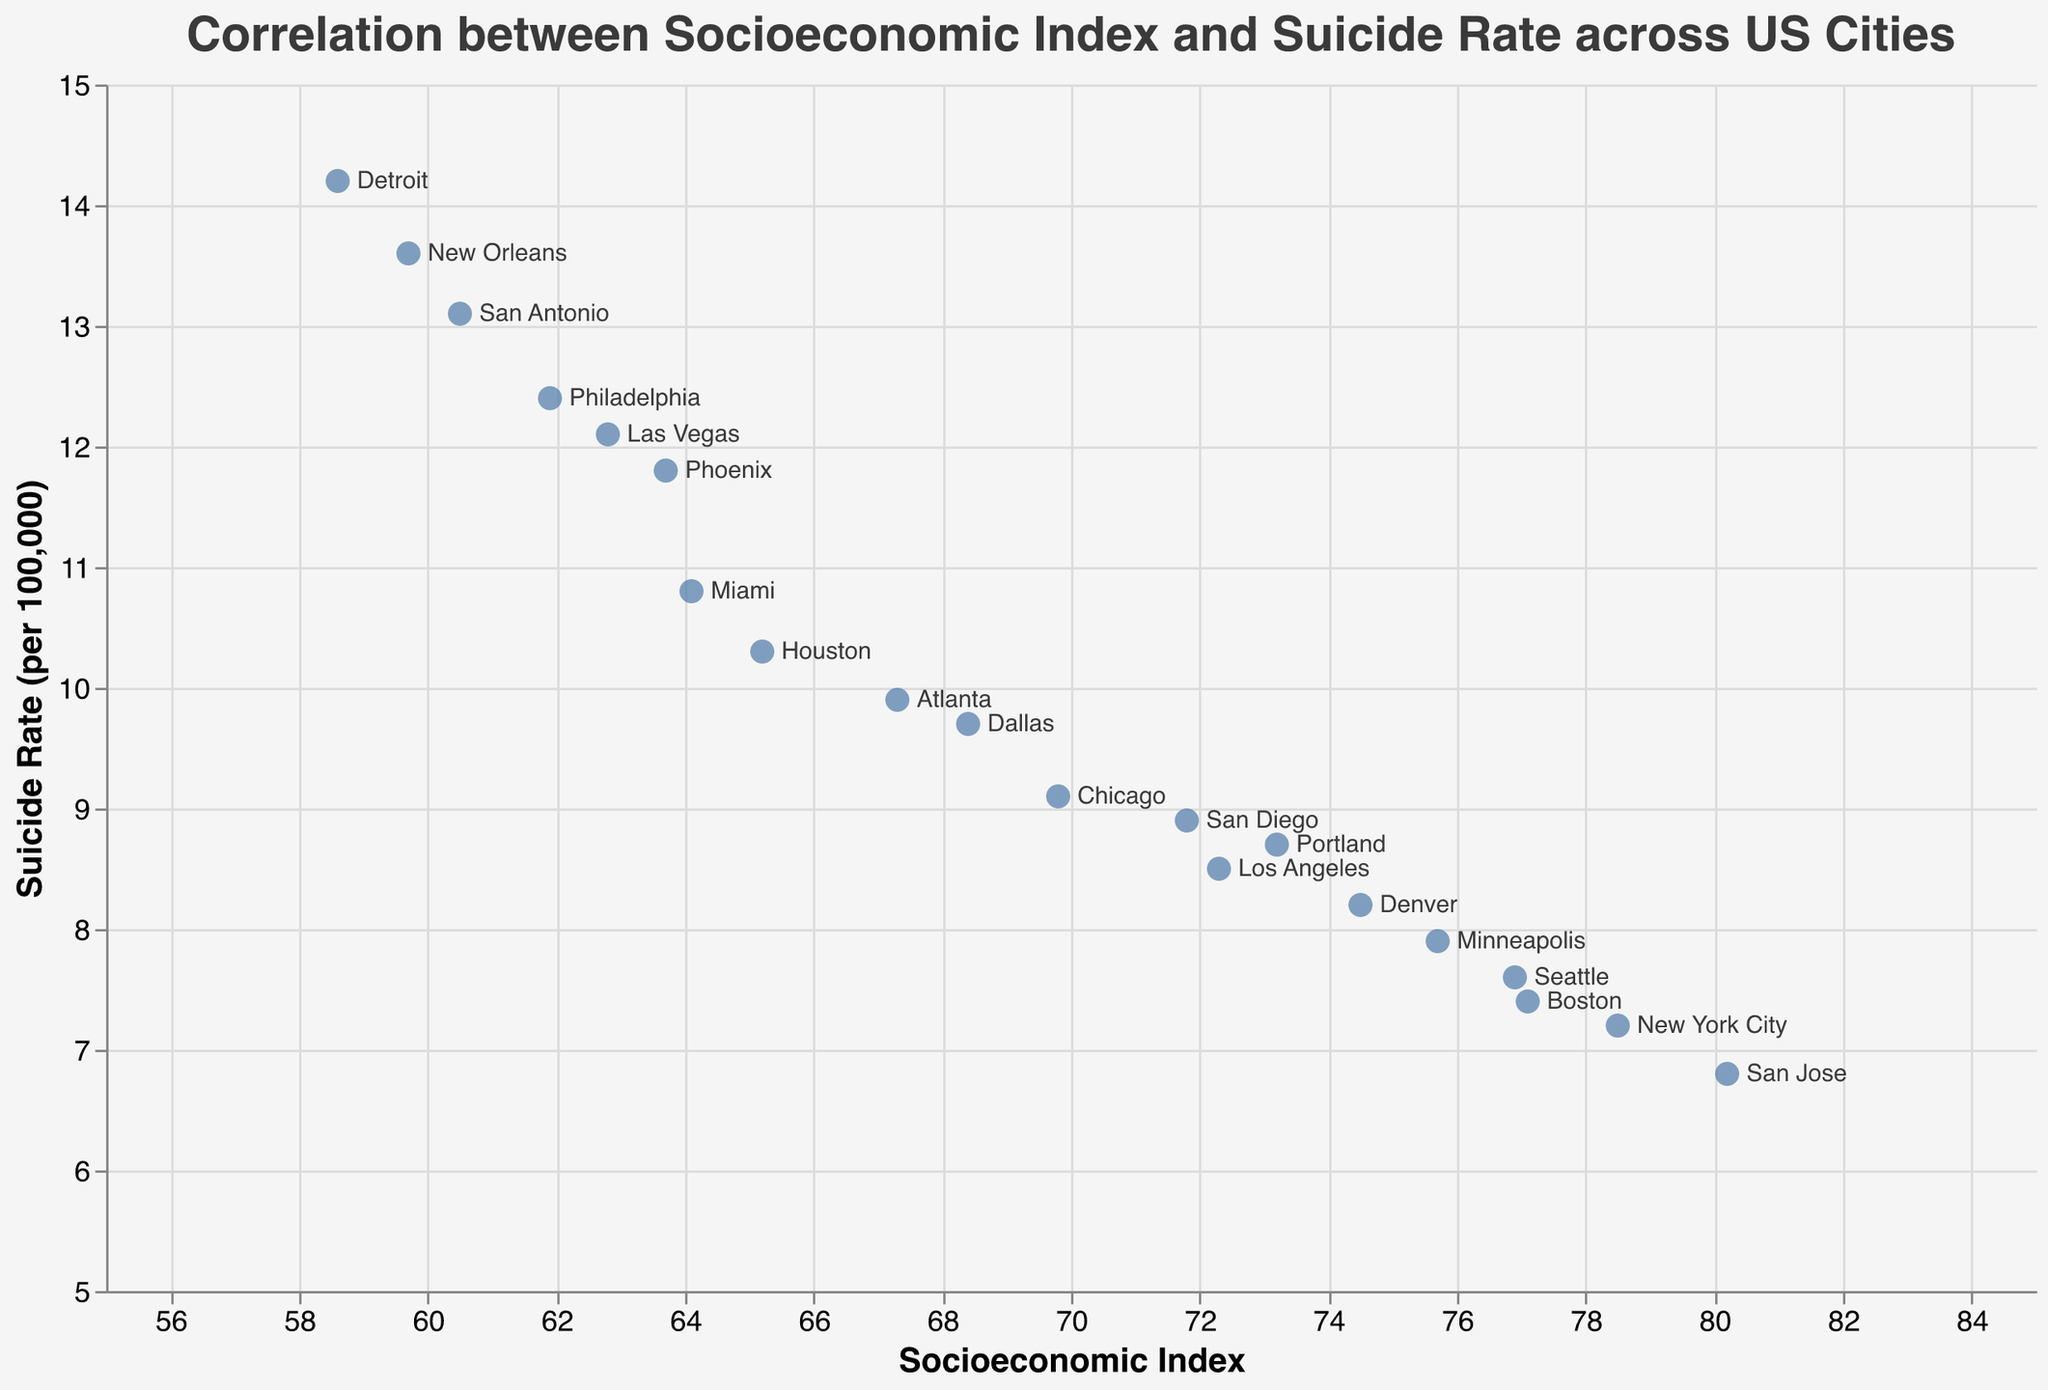What is the overall trend between Socioeconomic Index and Suicide Rate in the figure? By observing the scatter plot, as the Socioeconomic Index increases, the Suicide Rate tends to decrease, indicating a negative correlation.
Answer: Negative correlation Which city has the highest suicide rate? Locate the point with the highest value on the suicide rate axis (y-axis), corresponding to Detroit with a suicide rate of 14.2 per 100k.
Answer: Detroit What is the suicide rate in New York City? Identify New York City's point on the plot, positioned at a Socioeconomic Index of 78.5, and observe the corresponding suicide rate on the y-axis.
Answer: 7.2 How does the suicide rate in Las Vegas compare to that in San Diego? Find both cities' points on the plot, with Las Vegas at a suicide rate of 12.1 and San Diego at 8.9, showing that Las Vegas's rate is higher.
Answer: Las Vegas has a higher suicide rate Which city has the lowest Socioeconomic Index, and what is its suicide rate? Locate the point with the lowest value on the Socioeconomic Index axis (x-axis) which is Detroit with a Socioeconomic Index of 58.6 and a suicide rate of 14.2.
Answer: Detroit, 14.2 What is the difference in suicide rates between San Antonio and San Jose? Find San Antonio at a suicide rate of 13.1 and San Jose at 6.8, then compute the difference as 13.1 - 6.8 = 6.3.
Answer: 6.3 What is the median Socioeconomic Index among the cities plotted? Sort the Socioeconomic Index values and find the middle value. With 20 cities, the median lies between the 10th and 11th indexes, which are 69.8 and 72.3. The median is (69.8 + 72.3)/2 = 71.05.
Answer: 71.05 What is the average suicide rate across all cities? Sum the suicide rates and divide by the number of cities (20), calculated as (7.2 + 8.5 + 9.1 + 10.3 + 11.8 + 12.4 + 13.1 + 8.9 + 9.7 + 6.8 + 7.6 + 8.2 + 7.4 + 10.8 + 9.9 + 14.2 + 7.9 + 8.7 + 12.1 + 13.6)/20 = 10.02.
Answer: 10.02 Which two cities have the most similar Socioeconomic Index values? Compare Socioeconomic Index values to find the closest pair, which are Miami (64.1) and Houston (65.2) with a difference of 1.1.
Answer: Miami and Houston 